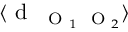Convert formula to latex. <formula><loc_0><loc_0><loc_500><loc_500>\langle d _ { O _ { 1 } O _ { 2 } } \rangle</formula> 